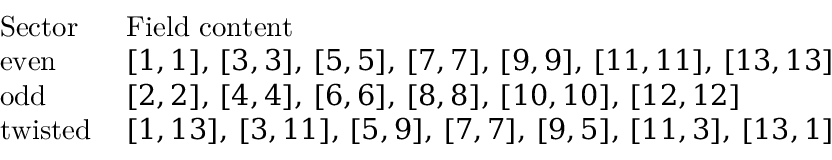<formula> <loc_0><loc_0><loc_500><loc_500>\begin{array} { l l } { S e c t o r \ \ } & { F i e l d c o n t e n t } \\ { e v e n } & { [ 1 , 1 ] , \, [ 3 , 3 ] , \, [ 5 , 5 ] , \, [ 7 , 7 ] , \, [ 9 , 9 ] , \, [ 1 1 , 1 1 ] , \, [ 1 3 , 1 3 ] } \\ { o d d } & { [ 2 , 2 ] , \, [ 4 , 4 ] , \, [ 6 , 6 ] , \, [ 8 , 8 ] , \, [ 1 0 , 1 0 ] , \, [ 1 2 , 1 2 ] } \\ { t w i s t e d } & { [ 1 , 1 3 ] , \, [ 3 , 1 1 ] , \, [ 5 , 9 ] , \, [ 7 , 7 ] , \, [ 9 , 5 ] , \, [ 1 1 , 3 ] , \, [ 1 3 , 1 ] } \end{array}</formula> 